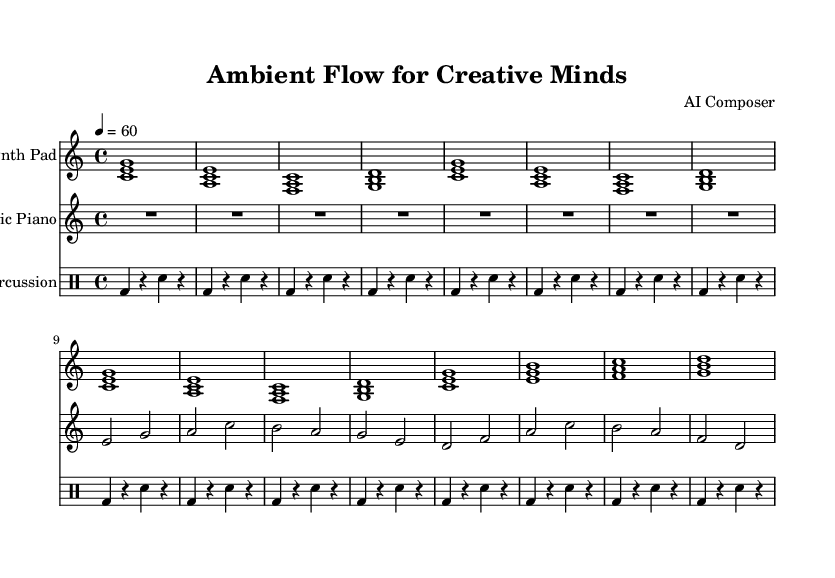What is the key signature of this music? The key signature is C major, which is indicated at the beginning of the score. There are no sharps or flats shown, confirming it is in the key of C major.
Answer: C major What is the time signature of this piece? The time signature is 4/4, which is indicated at the beginning of the score. This means there are four beats per measure, and the quarter note gets one beat.
Answer: 4/4 What is the tempo marking? The tempo marking is 60 beats per minute, as shown by the "4 = 60" at the beginning of the global section. This indicates a moderate pace for the music.
Answer: 60 How many repetitions are in the introduction of the synth pad? The introduction section of the synth pad contains a "repeat unfold 2" instruction, meaning the four chords are played two times. The reader can see this visually indicated in the notation.
Answer: 2 Which instrument plays the main theme first? The main theme is presented by the "Synth Pad" instrument as represented by the first staff in the score. This is visually distinguishable by the layout of the staves.
Answer: Synth Pad How many measures are in Theme A for the synth pad? Theme A consists of 8 measures in total. This can be counted by looking at the number of musical bars drawn within the theme section for the synth pad.
Answer: 8 What type of percussion is used in the piece? The percussion section specifically uses a bass drum and snare drum, as indicated by the notation styles used in the drum staff. The notation clearly shows which drums are being played.
Answer: Bass drum and snare drum 